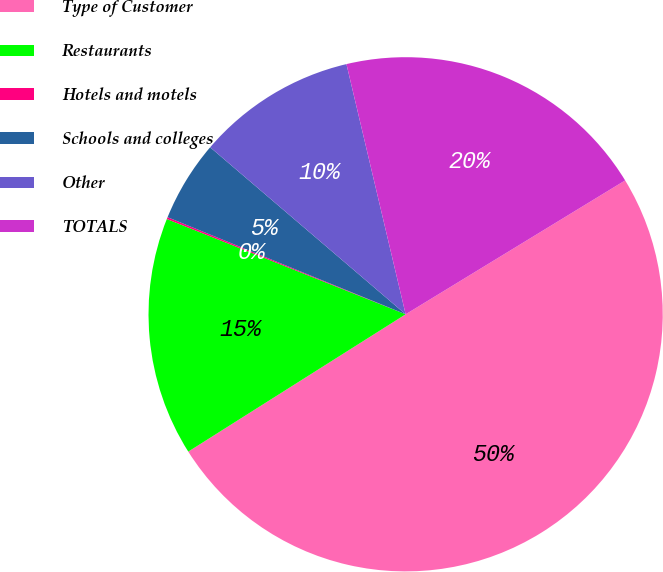Convert chart. <chart><loc_0><loc_0><loc_500><loc_500><pie_chart><fcel>Type of Customer<fcel>Restaurants<fcel>Hotels and motels<fcel>Schools and colleges<fcel>Other<fcel>TOTALS<nl><fcel>49.75%<fcel>15.01%<fcel>0.12%<fcel>5.09%<fcel>10.05%<fcel>19.98%<nl></chart> 